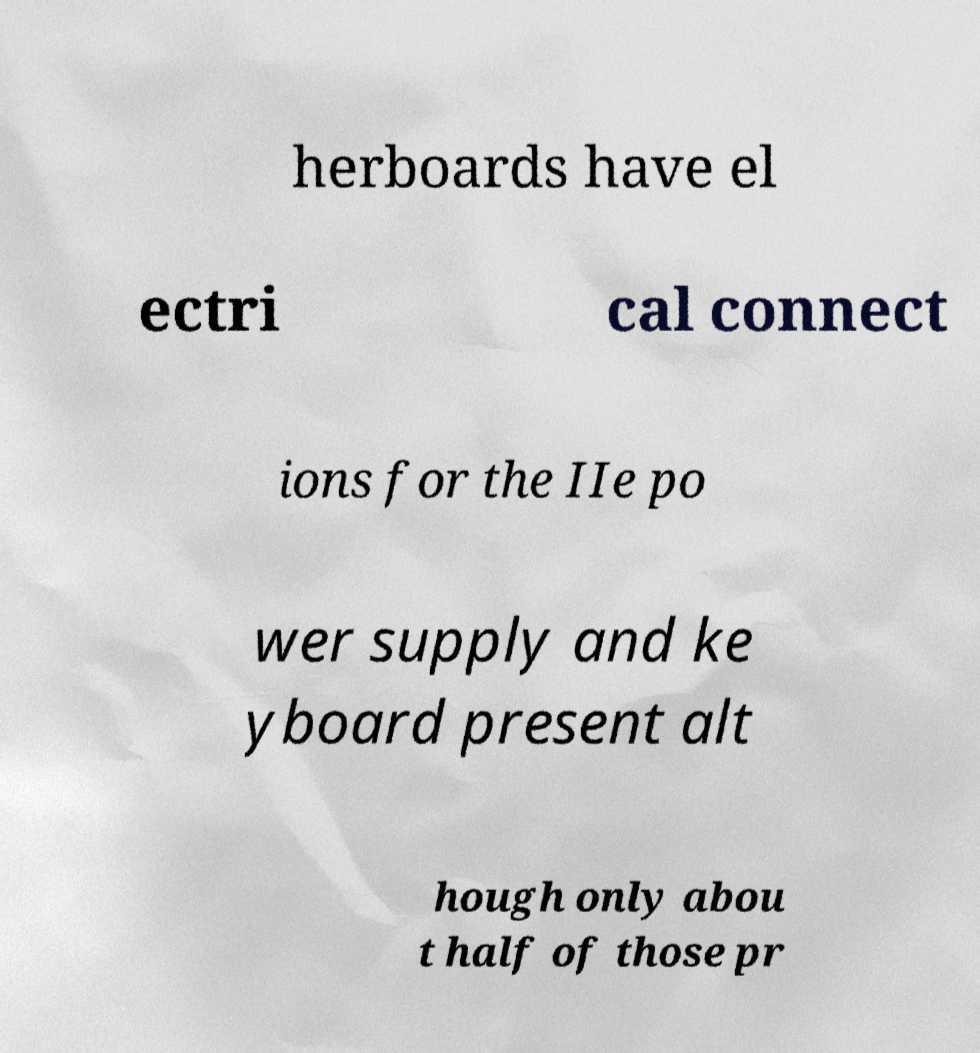Please read and relay the text visible in this image. What does it say? herboards have el ectri cal connect ions for the IIe po wer supply and ke yboard present alt hough only abou t half of those pr 